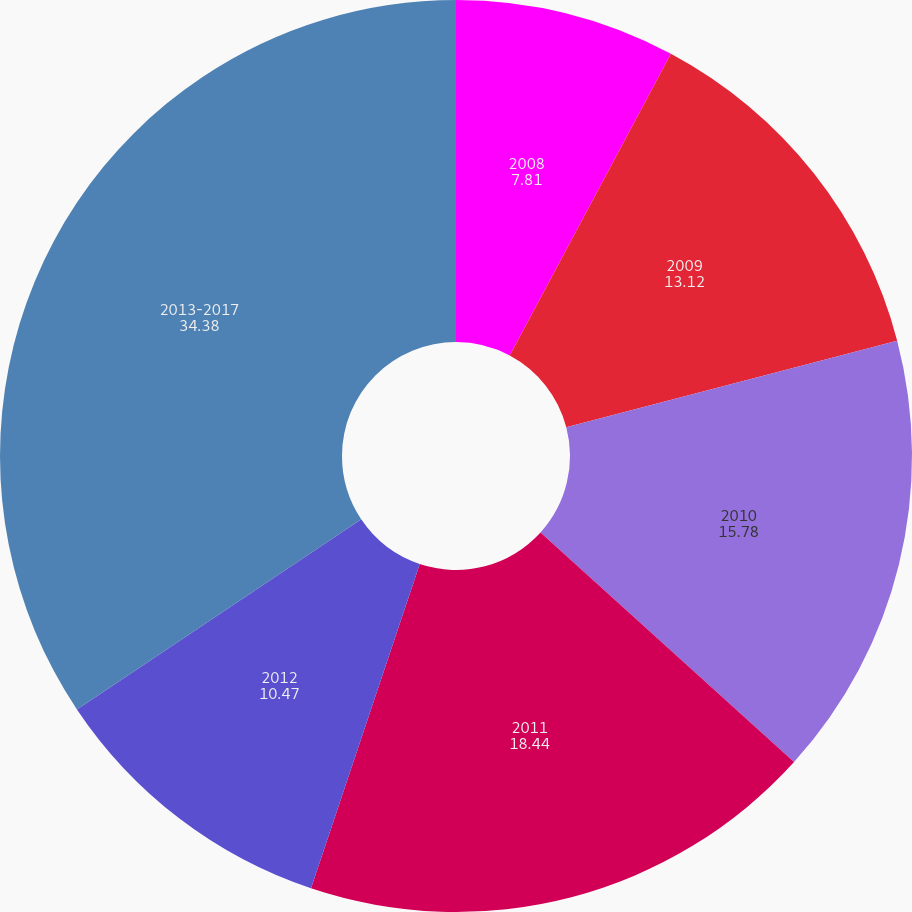Convert chart to OTSL. <chart><loc_0><loc_0><loc_500><loc_500><pie_chart><fcel>2008<fcel>2009<fcel>2010<fcel>2011<fcel>2012<fcel>2013-2017<nl><fcel>7.81%<fcel>13.12%<fcel>15.78%<fcel>18.44%<fcel>10.47%<fcel>34.38%<nl></chart> 